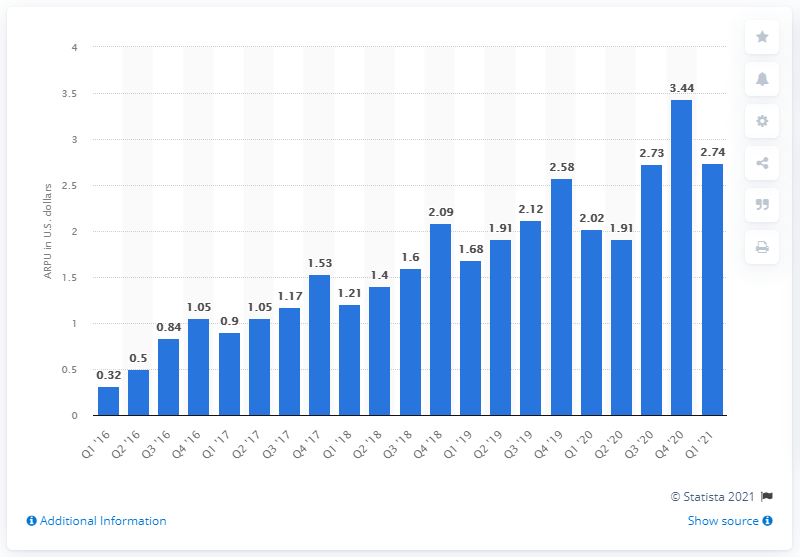Mention a couple of crucial points in this snapshot. As of the first quarter of 2021, Snap's average revenue per user (ARPU) was $2.74 per quarter. 